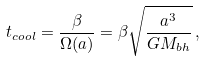Convert formula to latex. <formula><loc_0><loc_0><loc_500><loc_500>t _ { c o o l } = \frac { \beta } { \Omega ( a ) } = \beta \sqrt { \frac { a ^ { 3 } } { G M _ { b h } } } \, ,</formula> 